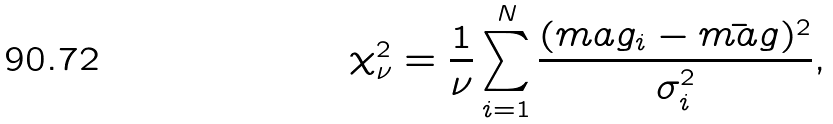<formula> <loc_0><loc_0><loc_500><loc_500>\chi ^ { 2 } _ { \nu } = \frac { 1 } { \nu } \sum ^ { N } _ { i = 1 } \frac { ( m a g _ { i } - \bar { m a g } ) ^ { 2 } } { \sigma ^ { 2 } _ { i } } ,</formula> 